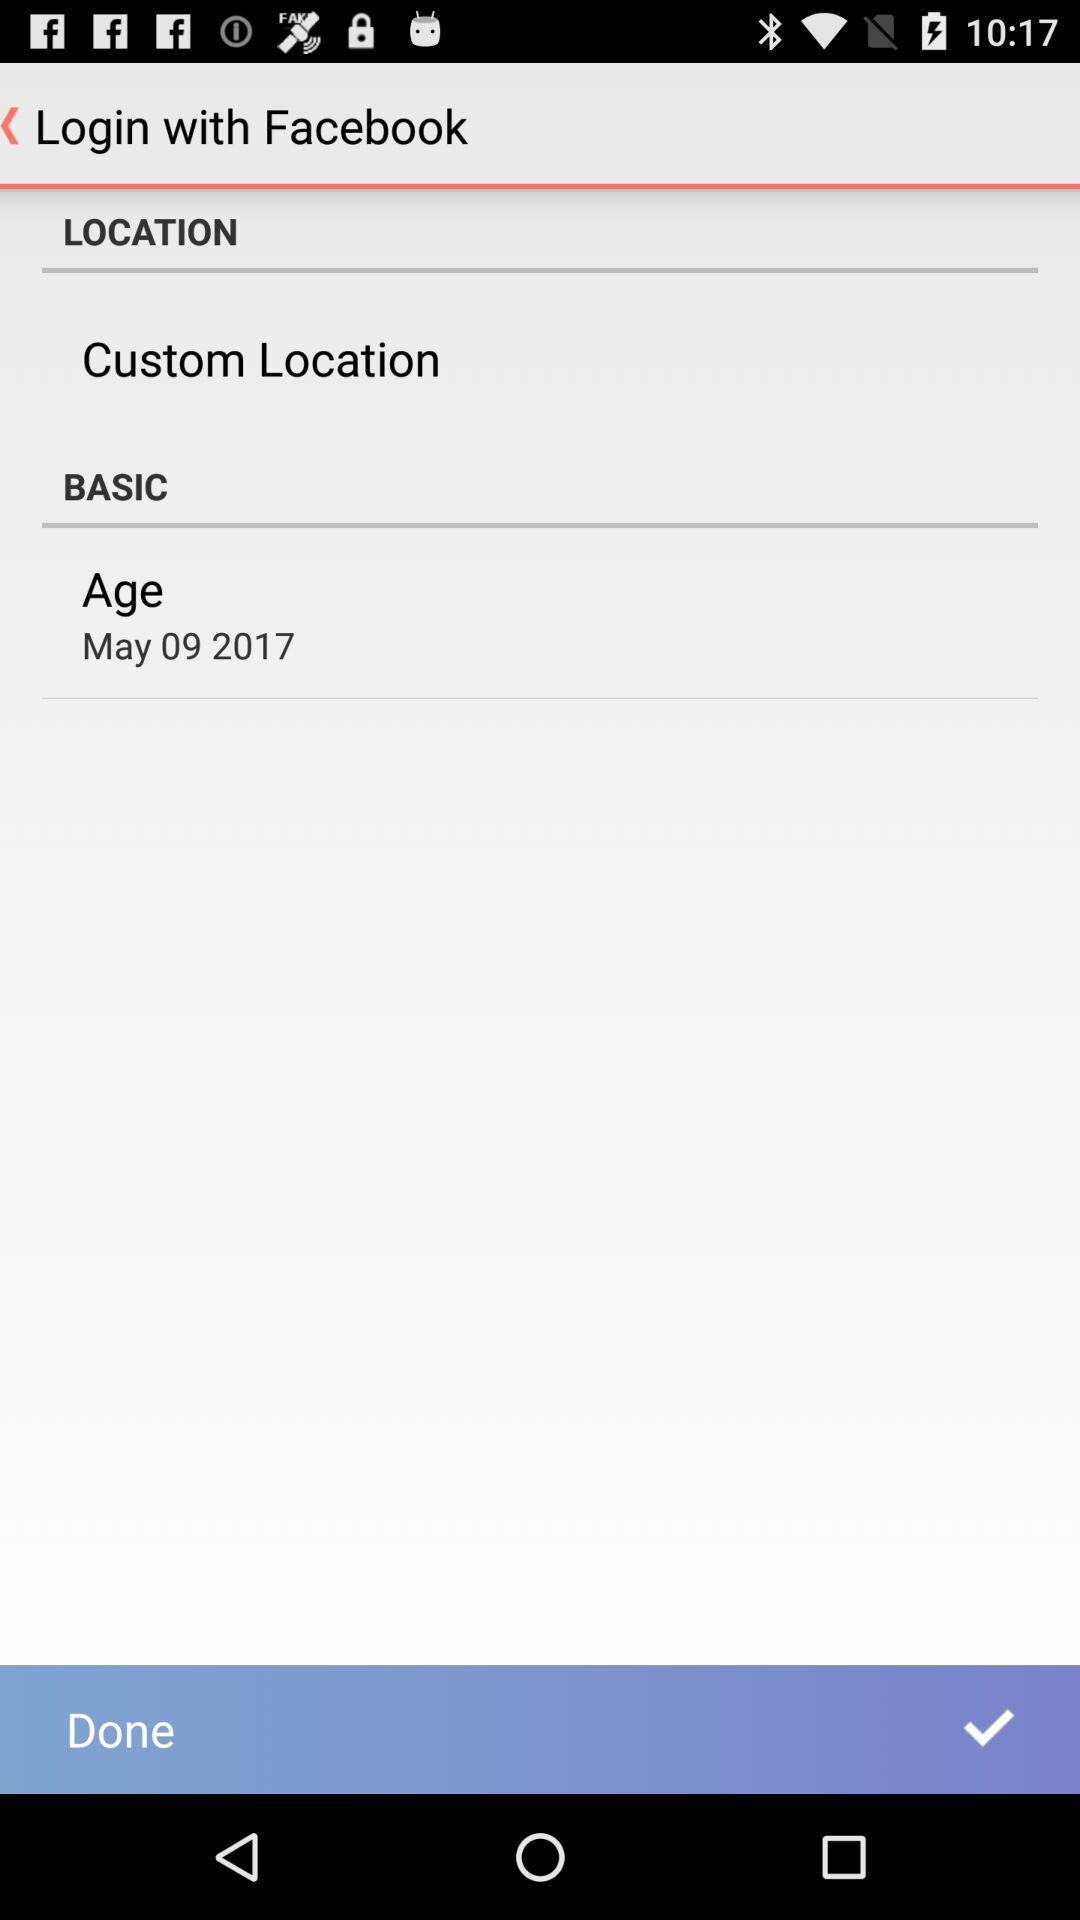What is the user's name?
When the provided information is insufficient, respond with <no answer>. <no answer> 